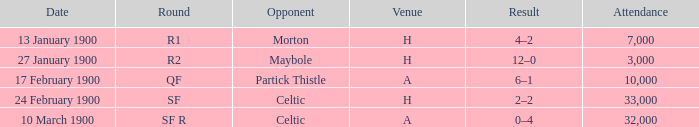Who played against in venue a on 17 february 1900? Partick Thistle. 